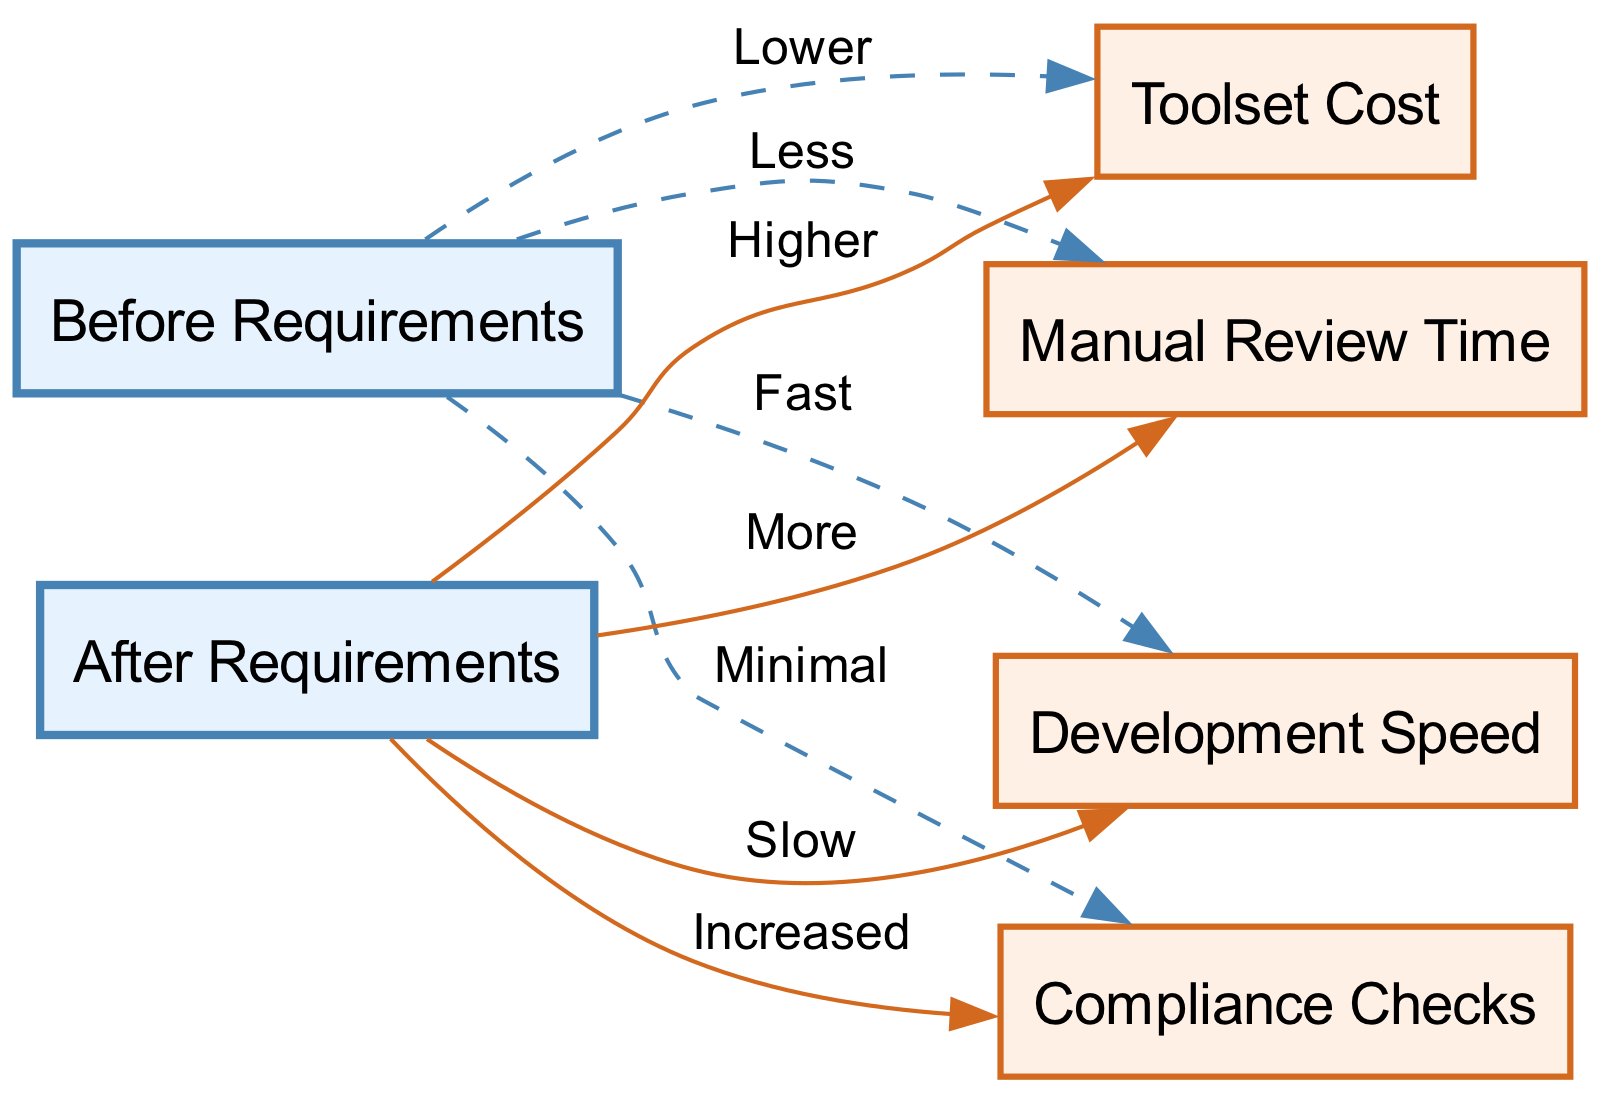What is the relationship between "Before Requirements" and "Toolset Cost"? The diagram indicates that before the requirements were implemented, the toolset cost was "Lower," showing a direct edge from the "Before Requirements" node to the "Toolset Cost" node with this label.
Answer: Lower How does "Manual Review Time" compare before and after the new requirements? The relationship in the diagram shows that before the new requirements, there was "Less" manual review time, while after the requirements, it increased to "More." This contrast can be seen in the labels of the edges between the respective nodes.
Answer: More What is the impact on "Development Speed" after implementing the new requirements? The diagram shows that development speed went from "Fast" before the requirements to "Slow" after. This transition is captured by the edge connecting the "Development Speed" node to both the "Before Requirements" and "After Requirements" nodes with respective labels.
Answer: Slow How many edges are displayed in the diagram? Counting the edges in the diagram reveals there are a total of 6 edges that connect various nodes as indicated by the relationships defined in the data structure.
Answer: 6 What effect do the new compliance requirements have on "Compliance Checks"? The graph indicates that compliance checks were "Minimal" before the requirements but increased to "Increased" after, represented by the edges between the "Before Requirements" and "After Requirements" nodes connected to the "Compliance Checks" node with corresponding labels.
Answer: Increased Which node indicates a decrease in development efficiency? The edges leading to the "Development Speed" node specify that after the requirements, the speed is "Slow," which signifies a decrease in development efficiency when transitioning from "Fast." This creates a clear relationship denoting a negative impact.
Answer: Slow What color represents the nodes tied to "After Requirements"? In the diagram, the nodes associated with "After Requirements" are shown filled with a specific color, allowing for a quick visual identification of them as a group – in this case, they are colored with a light red shade (#E6F3FF) that contrasts with the other nodes.
Answer: Light red What was the state of compliance checks before the new requirements? The edge linking "Before Requirements" to "Compliance Checks" gives the label "Minimal," indicating the level of compliance checks prior to implementing the new requirements, representing it directly in the relationship shown.
Answer: Minimal 